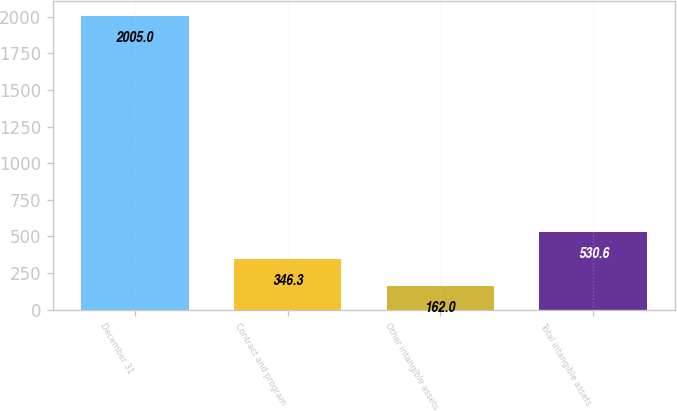Convert chart to OTSL. <chart><loc_0><loc_0><loc_500><loc_500><bar_chart><fcel>December 31<fcel>Contract and program<fcel>Other intangible assets<fcel>Total intangible assets<nl><fcel>2005<fcel>346.3<fcel>162<fcel>530.6<nl></chart> 